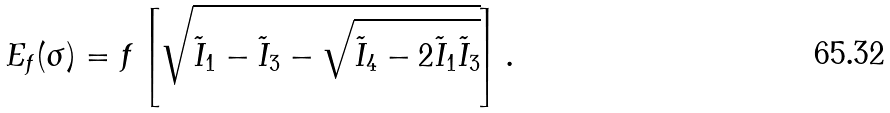<formula> <loc_0><loc_0><loc_500><loc_500>E _ { f } ( \sigma ) = f \left [ \sqrt { \tilde { I } _ { 1 } - \tilde { I } _ { 3 } - \sqrt { \tilde { I } _ { 4 } - 2 \tilde { I } _ { 1 } \tilde { I } _ { 3 } } } \right ] .</formula> 